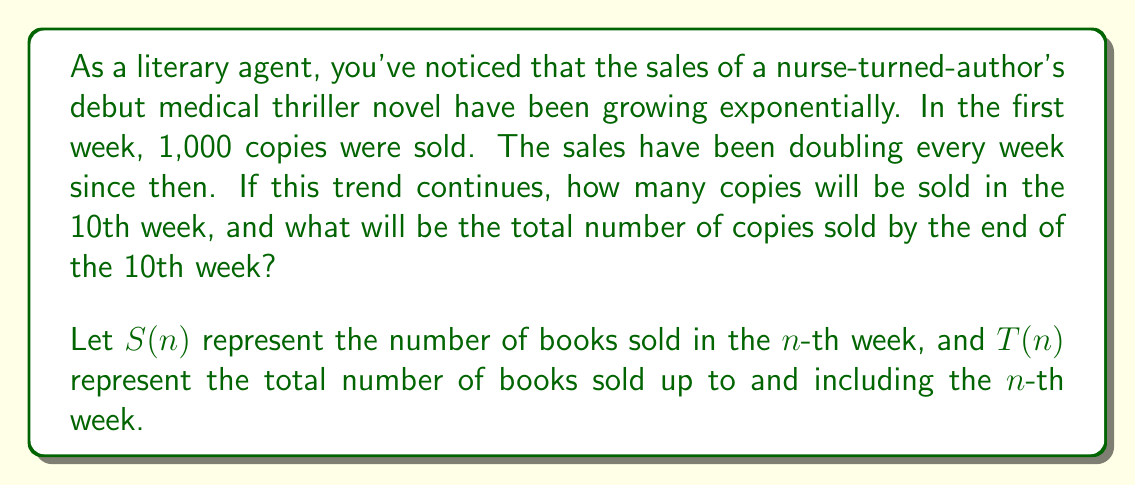Give your solution to this math problem. To solve this problem, we'll use an exponential growth model and the formula for the sum of a geometric series.

1. Number of copies sold in the 10th week:
   The sales are doubling every week, so we can use the exponential growth formula:
   $S(n) = S(1) \cdot 2^{n-1}$
   where $S(1) = 1,000$ (initial sales) and $n = 10$ (week number)

   $S(10) = 1,000 \cdot 2^{10-1} = 1,000 \cdot 2^9 = 1,000 \cdot 512 = 512,000$

2. Total number of copies sold by the end of the 10th week:
   This is the sum of a geometric series with:
   First term $a = 1,000$
   Common ratio $r = 2$
   Number of terms $n = 10$

   We use the formula for the sum of a geometric series:
   $$T(n) = \frac{a(1-r^n)}{1-r} = \frac{1,000(1-2^{10})}{1-2}$$

   $T(10) = \frac{1,000(1-1024)}{-1} = 1,000 \cdot 1023 = 1,023,000$
Answer: In the 10th week, 512,000 copies will be sold.
The total number of copies sold by the end of the 10th week will be 1,023,000. 